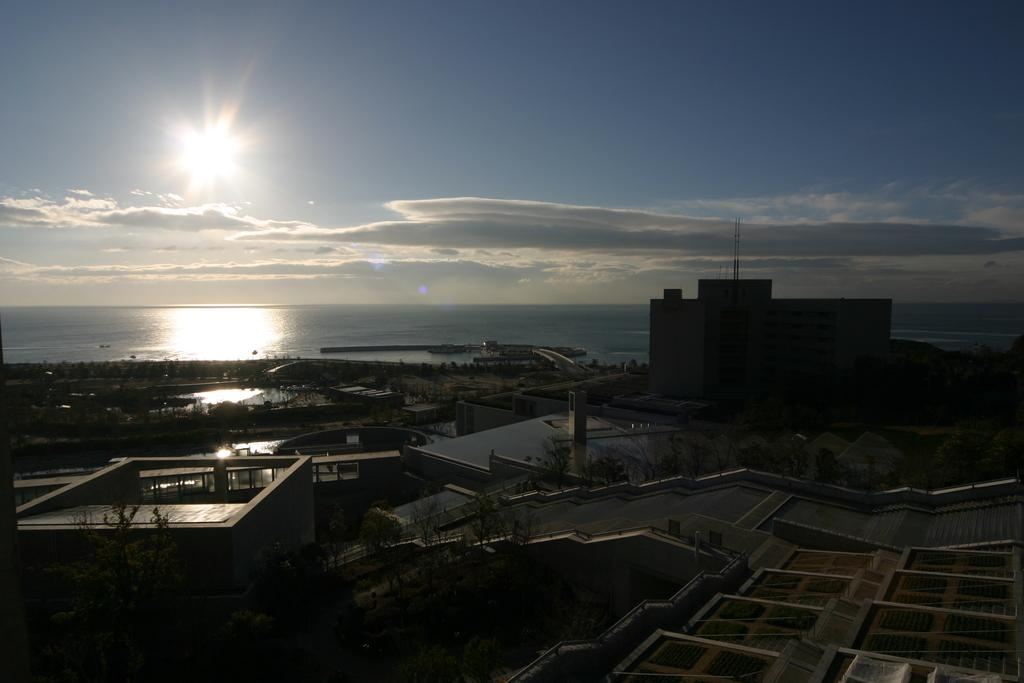What type of structures can be seen in the image? There are houses in the image. What other natural elements are present in the image? There are trees in the image. What can be seen in the distance in the image? There is water visible in the background of the image. How would you describe the weather based on the image? The sky is clear in the background of the image, suggesting good weather. What type of joke is being told by the oven in the image? There is no oven present in the image, so it is not possible to answer that question. 